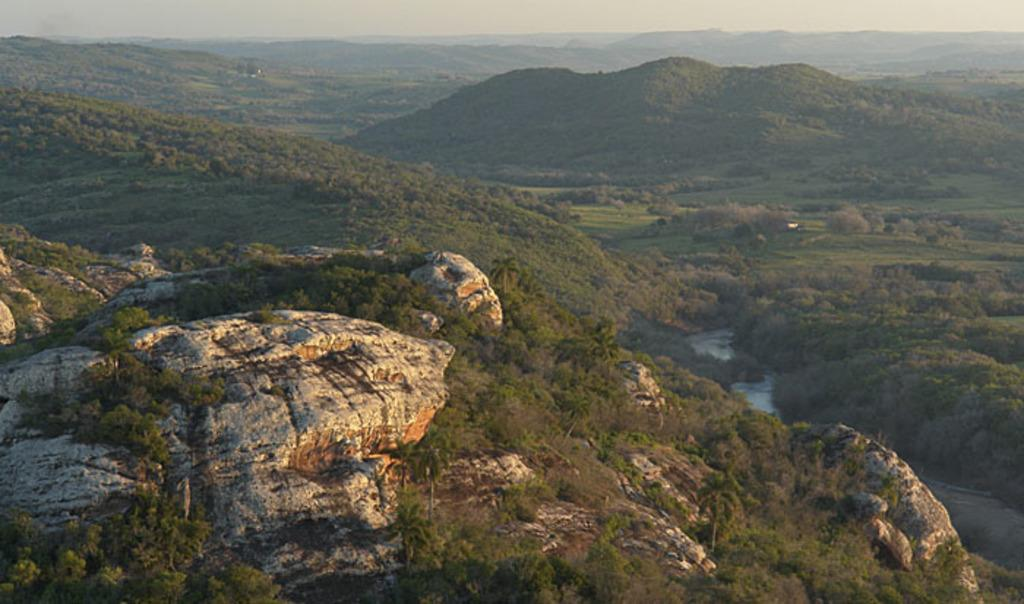What is the main geographical feature in the image? There is a mountain in the image. What can be seen on the mountain? There are trees on the mountain. What else is visible in the image besides the mountain? There is water and the sky visible in the image. Where is the coil located in the image? There is no coil present in the image. What type of basin can be seen at the top of the mountain? There is no basin present in the image; it features a mountain with trees. 